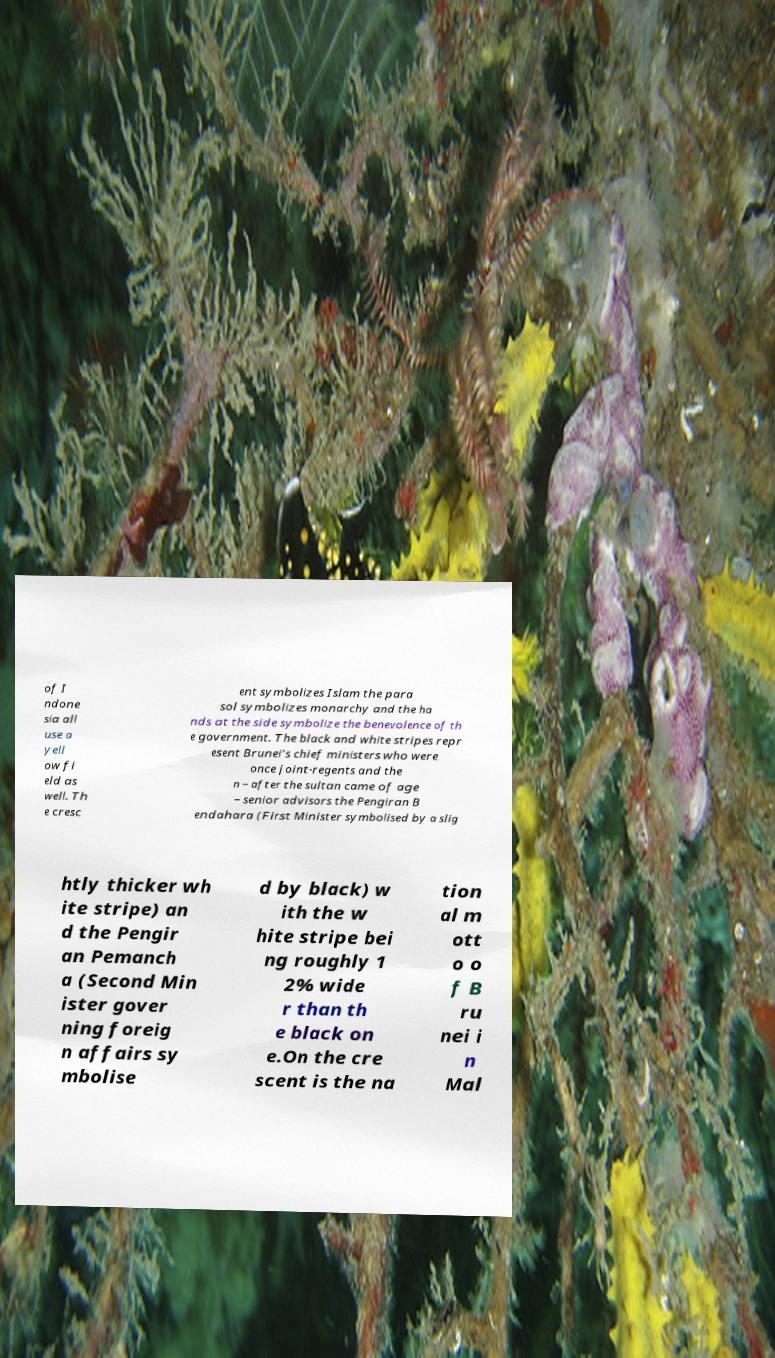Can you accurately transcribe the text from the provided image for me? of I ndone sia all use a yell ow fi eld as well. Th e cresc ent symbolizes Islam the para sol symbolizes monarchy and the ha nds at the side symbolize the benevolence of th e government. The black and white stripes repr esent Brunei's chief ministers who were once joint-regents and the n – after the sultan came of age – senior advisors the Pengiran B endahara (First Minister symbolised by a slig htly thicker wh ite stripe) an d the Pengir an Pemanch a (Second Min ister gover ning foreig n affairs sy mbolise d by black) w ith the w hite stripe bei ng roughly 1 2% wide r than th e black on e.On the cre scent is the na tion al m ott o o f B ru nei i n Mal 